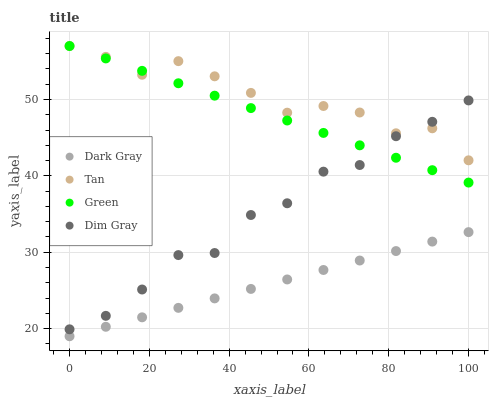Does Dark Gray have the minimum area under the curve?
Answer yes or no. Yes. Does Tan have the maximum area under the curve?
Answer yes or no. Yes. Does Dim Gray have the minimum area under the curve?
Answer yes or no. No. Does Dim Gray have the maximum area under the curve?
Answer yes or no. No. Is Green the smoothest?
Answer yes or no. Yes. Is Dim Gray the roughest?
Answer yes or no. Yes. Is Tan the smoothest?
Answer yes or no. No. Is Tan the roughest?
Answer yes or no. No. Does Dark Gray have the lowest value?
Answer yes or no. Yes. Does Dim Gray have the lowest value?
Answer yes or no. No. Does Green have the highest value?
Answer yes or no. Yes. Does Dim Gray have the highest value?
Answer yes or no. No. Is Dark Gray less than Dim Gray?
Answer yes or no. Yes. Is Dim Gray greater than Dark Gray?
Answer yes or no. Yes. Does Tan intersect Dim Gray?
Answer yes or no. Yes. Is Tan less than Dim Gray?
Answer yes or no. No. Is Tan greater than Dim Gray?
Answer yes or no. No. Does Dark Gray intersect Dim Gray?
Answer yes or no. No. 